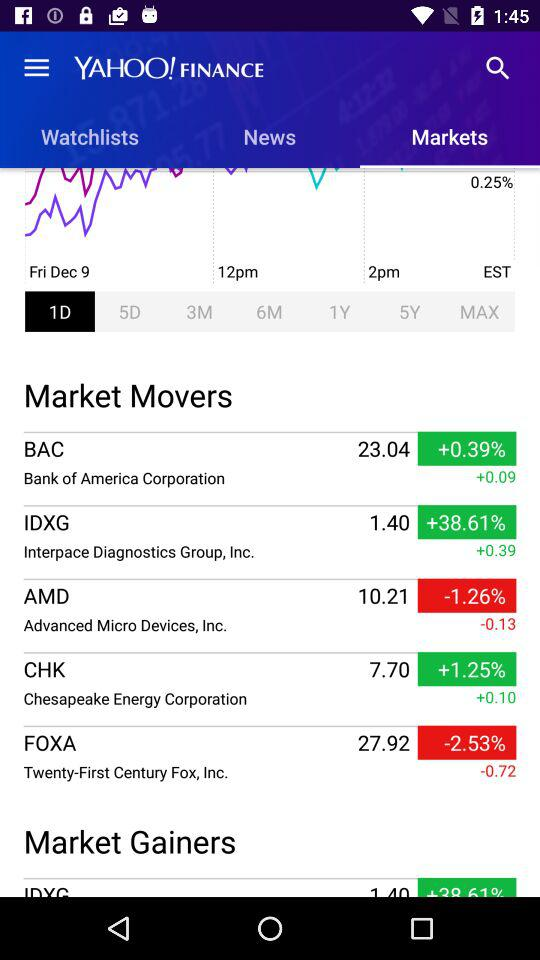What are the names of the different market movers listed? The different market movers are "BAC", "IDXG", "AMD", "CHK" and "FOXA". 